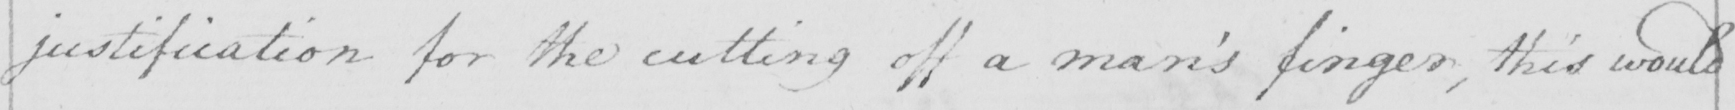Can you read and transcribe this handwriting? justification for the cutting off a man ' s finger , this would 